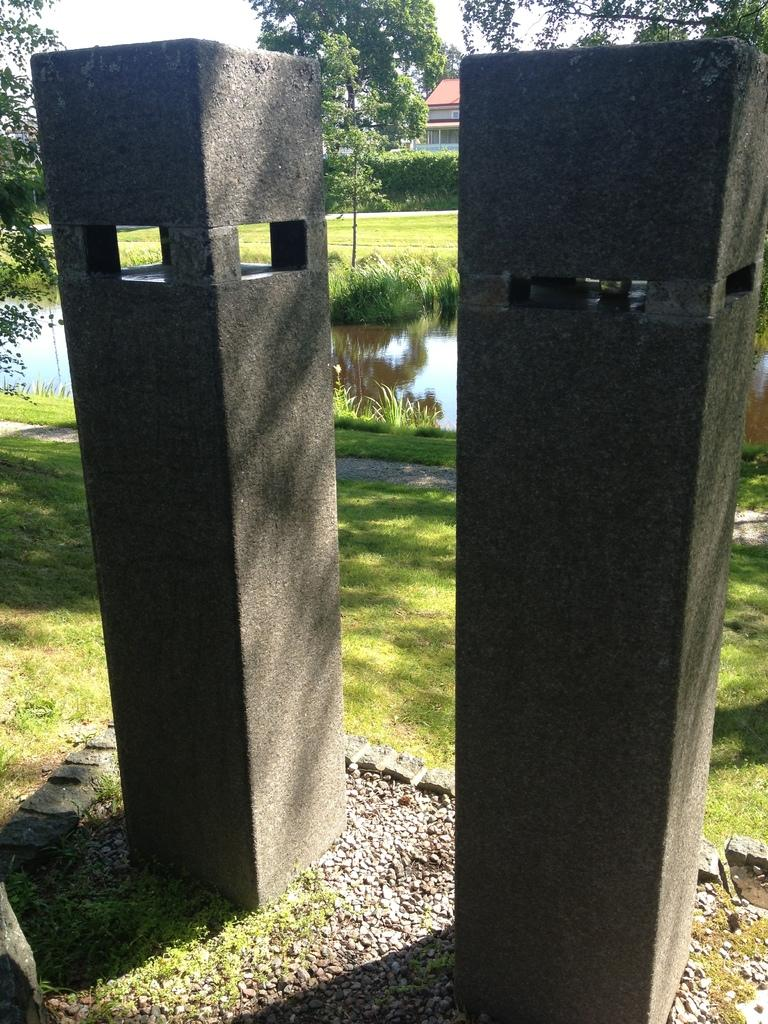What type of objects are on the ground in the image? There are stone objects on the ground in the image. What can be seen in the background of the image? In the background of the image, there is water, grass, trees, a house, and the sky. Can you describe the natural environment visible in the image? The natural environment includes grass, trees, and water. What type of structure is visible in the background of the image? There is a house in the background of the image. What type of body is visible in the image? There is no body present in the image; it features stone objects on the ground and a natural environment in the background. 